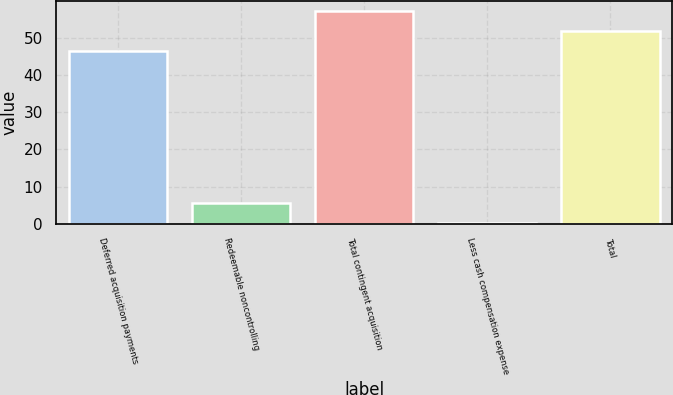Convert chart to OTSL. <chart><loc_0><loc_0><loc_500><loc_500><bar_chart><fcel>Deferred acquisition payments<fcel>Redeemable noncontrolling<fcel>Total contingent acquisition<fcel>Less cash compensation expense<fcel>Total<nl><fcel>46.4<fcel>5.7<fcel>57.09<fcel>0.2<fcel>51.9<nl></chart> 